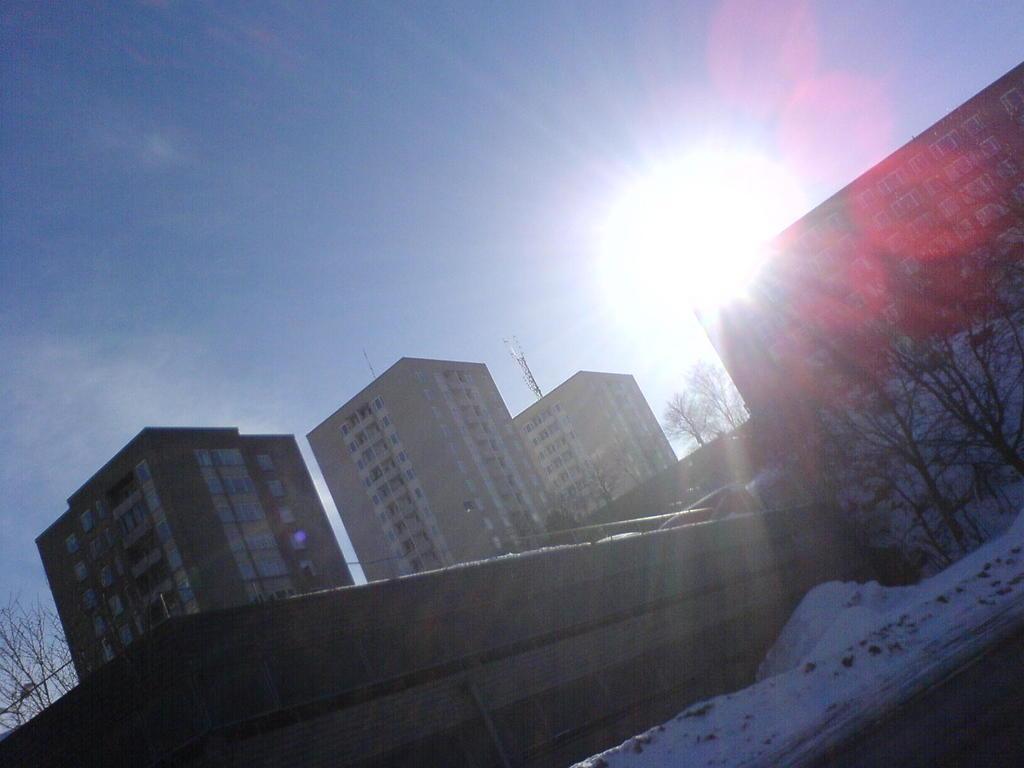Could you give a brief overview of what you see in this image? Here we can see trees, wall, snow, and buildings. In the background there is sky. 